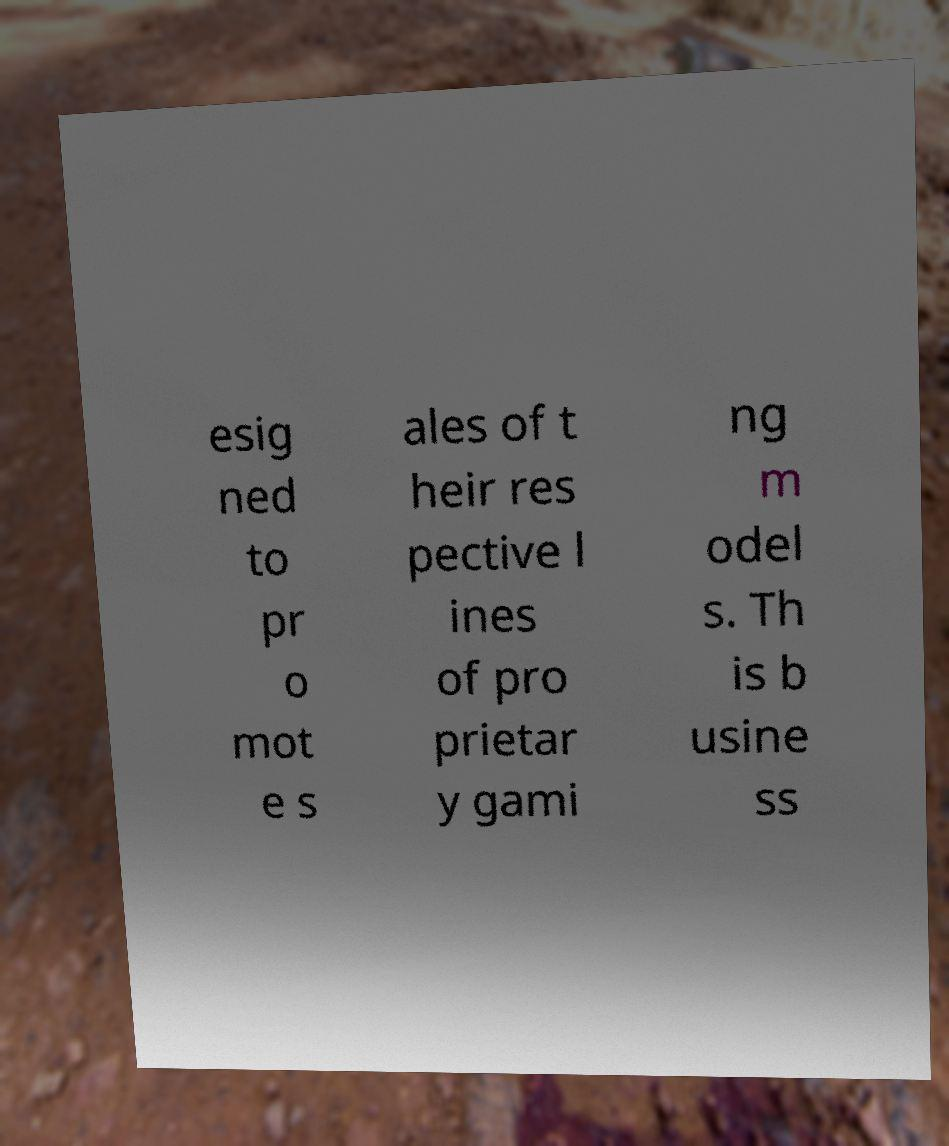Could you assist in decoding the text presented in this image and type it out clearly? esig ned to pr o mot e s ales of t heir res pective l ines of pro prietar y gami ng m odel s. Th is b usine ss 